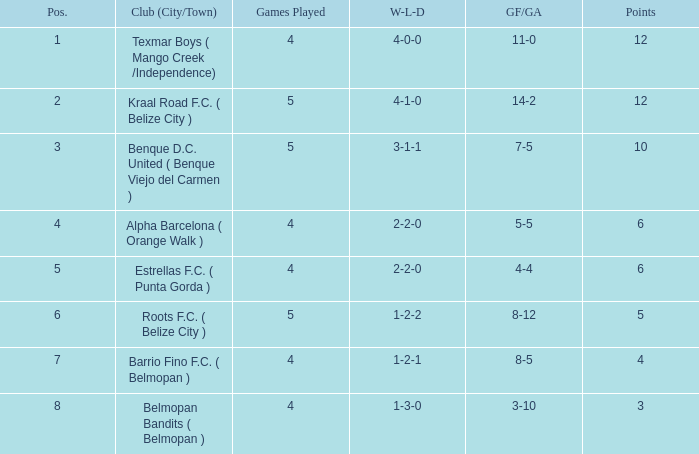What's the goals for/against with w-l-d being 3-1-1 7-5. 